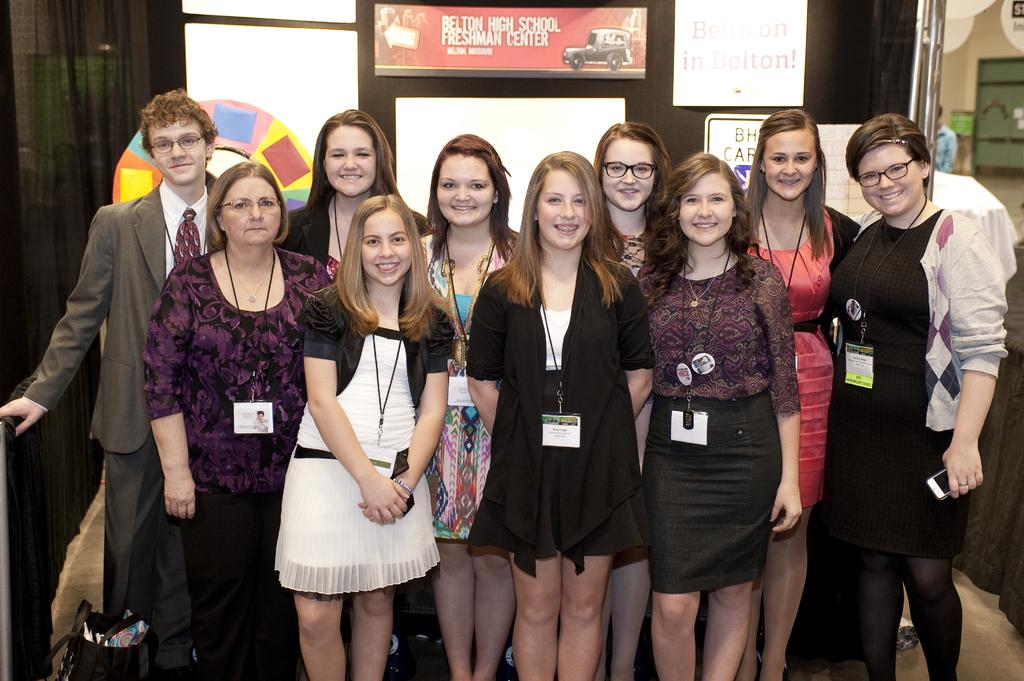How many people are in the image? There is a group of people in the image. What are the people wearing? The people are wearing clothes. Where are the people standing in the image? The people are standing in front of a wall. What can be seen in the bottom left of the image? There is a bag in the bottom left of the image. How many rings does the goat have on its neck in the image? There is no goat present in the image, and therefore no rings on its neck. 